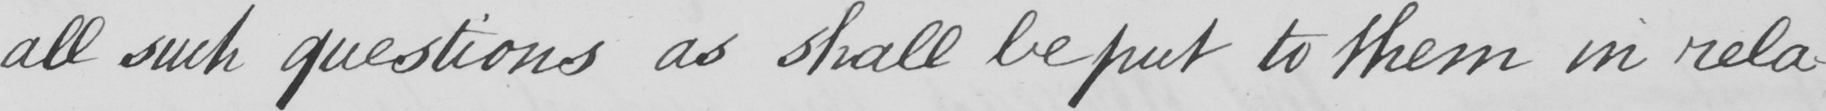What is written in this line of handwriting? all such questions as shall be put to them in rela- 